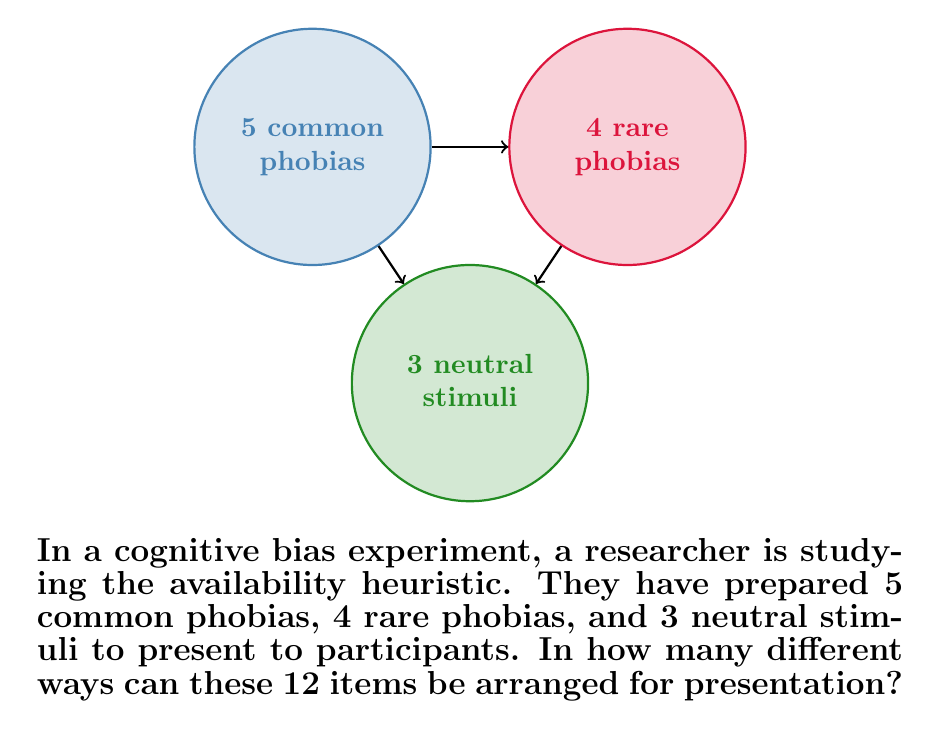Solve this math problem. To solve this problem, we need to use the fundamental principle of counting, specifically the concept of permutations.

1) We have a total of 12 distinct items:
   - 5 common phobias
   - 4 rare phobias
   - 3 neutral stimuli

2) Since all items are distinct and we need to arrange all of them, this is a straightforward permutation problem.

3) The number of permutations of n distinct objects is given by $n!$

4) In this case, $n = 5 + 4 + 3 = 12$

5) Therefore, the number of ways to arrange these items is:

   $$12! = 12 \times 11 \times 10 \times 9 \times 8 \times 7 \times 6 \times 5 \times 4 \times 3 \times 2 \times 1$$

6) Computing this:
   $$12! = 479,001,600$$

This large number demonstrates why controlling for order effects is crucial in cognitive bias experiments, as each arrangement could potentially influence the results differently.
Answer: $479,001,600$ 